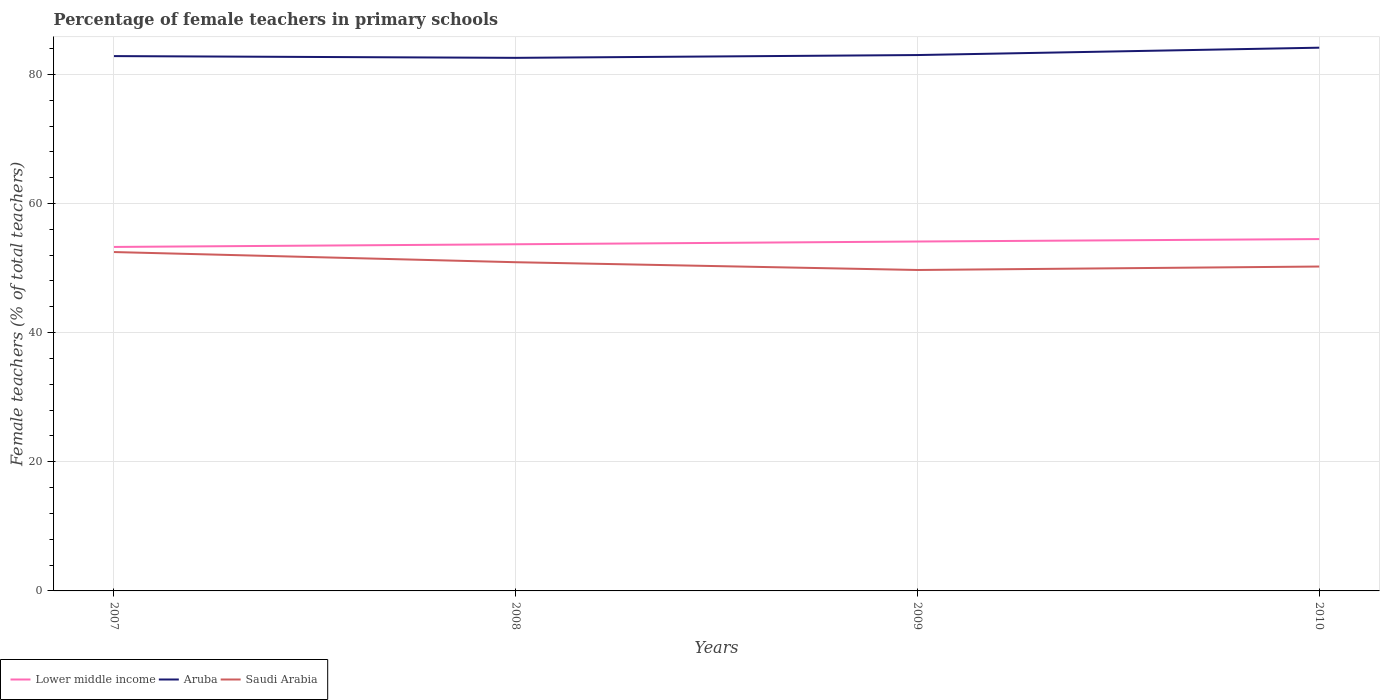How many different coloured lines are there?
Offer a terse response. 3. Does the line corresponding to Aruba intersect with the line corresponding to Saudi Arabia?
Offer a terse response. No. Is the number of lines equal to the number of legend labels?
Ensure brevity in your answer.  Yes. Across all years, what is the maximum percentage of female teachers in Aruba?
Your answer should be compact. 82.56. In which year was the percentage of female teachers in Aruba maximum?
Your answer should be compact. 2008. What is the total percentage of female teachers in Saudi Arabia in the graph?
Offer a terse response. 0.67. What is the difference between the highest and the second highest percentage of female teachers in Aruba?
Your answer should be compact. 1.57. How many lines are there?
Provide a succinct answer. 3. Does the graph contain grids?
Ensure brevity in your answer.  Yes. Where does the legend appear in the graph?
Your response must be concise. Bottom left. How many legend labels are there?
Offer a very short reply. 3. What is the title of the graph?
Your answer should be compact. Percentage of female teachers in primary schools. Does "Liberia" appear as one of the legend labels in the graph?
Your answer should be compact. No. What is the label or title of the X-axis?
Provide a succinct answer. Years. What is the label or title of the Y-axis?
Your response must be concise. Female teachers (% of total teachers). What is the Female teachers (% of total teachers) of Lower middle income in 2007?
Your response must be concise. 53.27. What is the Female teachers (% of total teachers) of Aruba in 2007?
Keep it short and to the point. 82.83. What is the Female teachers (% of total teachers) in Saudi Arabia in 2007?
Offer a terse response. 52.48. What is the Female teachers (% of total teachers) of Lower middle income in 2008?
Give a very brief answer. 53.69. What is the Female teachers (% of total teachers) in Aruba in 2008?
Offer a very short reply. 82.56. What is the Female teachers (% of total teachers) of Saudi Arabia in 2008?
Your answer should be very brief. 50.91. What is the Female teachers (% of total teachers) of Lower middle income in 2009?
Keep it short and to the point. 54.11. What is the Female teachers (% of total teachers) of Aruba in 2009?
Provide a succinct answer. 82.99. What is the Female teachers (% of total teachers) of Saudi Arabia in 2009?
Your response must be concise. 49.7. What is the Female teachers (% of total teachers) in Lower middle income in 2010?
Ensure brevity in your answer.  54.49. What is the Female teachers (% of total teachers) of Aruba in 2010?
Ensure brevity in your answer.  84.13. What is the Female teachers (% of total teachers) in Saudi Arabia in 2010?
Your answer should be very brief. 50.24. Across all years, what is the maximum Female teachers (% of total teachers) of Lower middle income?
Your response must be concise. 54.49. Across all years, what is the maximum Female teachers (% of total teachers) of Aruba?
Keep it short and to the point. 84.13. Across all years, what is the maximum Female teachers (% of total teachers) of Saudi Arabia?
Keep it short and to the point. 52.48. Across all years, what is the minimum Female teachers (% of total teachers) of Lower middle income?
Ensure brevity in your answer.  53.27. Across all years, what is the minimum Female teachers (% of total teachers) in Aruba?
Provide a short and direct response. 82.56. Across all years, what is the minimum Female teachers (% of total teachers) in Saudi Arabia?
Provide a succinct answer. 49.7. What is the total Female teachers (% of total teachers) in Lower middle income in the graph?
Keep it short and to the point. 215.56. What is the total Female teachers (% of total teachers) in Aruba in the graph?
Make the answer very short. 332.5. What is the total Female teachers (% of total teachers) of Saudi Arabia in the graph?
Offer a terse response. 203.33. What is the difference between the Female teachers (% of total teachers) in Lower middle income in 2007 and that in 2008?
Ensure brevity in your answer.  -0.41. What is the difference between the Female teachers (% of total teachers) of Aruba in 2007 and that in 2008?
Make the answer very short. 0.27. What is the difference between the Female teachers (% of total teachers) of Saudi Arabia in 2007 and that in 2008?
Give a very brief answer. 1.57. What is the difference between the Female teachers (% of total teachers) of Lower middle income in 2007 and that in 2009?
Provide a short and direct response. -0.84. What is the difference between the Female teachers (% of total teachers) of Aruba in 2007 and that in 2009?
Offer a terse response. -0.16. What is the difference between the Female teachers (% of total teachers) in Saudi Arabia in 2007 and that in 2009?
Your answer should be very brief. 2.78. What is the difference between the Female teachers (% of total teachers) in Lower middle income in 2007 and that in 2010?
Offer a very short reply. -1.22. What is the difference between the Female teachers (% of total teachers) of Aruba in 2007 and that in 2010?
Your response must be concise. -1.3. What is the difference between the Female teachers (% of total teachers) in Saudi Arabia in 2007 and that in 2010?
Offer a very short reply. 2.24. What is the difference between the Female teachers (% of total teachers) of Lower middle income in 2008 and that in 2009?
Your response must be concise. -0.42. What is the difference between the Female teachers (% of total teachers) of Aruba in 2008 and that in 2009?
Keep it short and to the point. -0.43. What is the difference between the Female teachers (% of total teachers) of Saudi Arabia in 2008 and that in 2009?
Provide a succinct answer. 1.2. What is the difference between the Female teachers (% of total teachers) of Lower middle income in 2008 and that in 2010?
Your answer should be compact. -0.8. What is the difference between the Female teachers (% of total teachers) of Aruba in 2008 and that in 2010?
Provide a short and direct response. -1.57. What is the difference between the Female teachers (% of total teachers) in Saudi Arabia in 2008 and that in 2010?
Make the answer very short. 0.67. What is the difference between the Female teachers (% of total teachers) in Lower middle income in 2009 and that in 2010?
Your answer should be compact. -0.38. What is the difference between the Female teachers (% of total teachers) in Aruba in 2009 and that in 2010?
Your answer should be compact. -1.14. What is the difference between the Female teachers (% of total teachers) in Saudi Arabia in 2009 and that in 2010?
Offer a terse response. -0.53. What is the difference between the Female teachers (% of total teachers) of Lower middle income in 2007 and the Female teachers (% of total teachers) of Aruba in 2008?
Your response must be concise. -29.28. What is the difference between the Female teachers (% of total teachers) of Lower middle income in 2007 and the Female teachers (% of total teachers) of Saudi Arabia in 2008?
Provide a short and direct response. 2.37. What is the difference between the Female teachers (% of total teachers) in Aruba in 2007 and the Female teachers (% of total teachers) in Saudi Arabia in 2008?
Keep it short and to the point. 31.92. What is the difference between the Female teachers (% of total teachers) in Lower middle income in 2007 and the Female teachers (% of total teachers) in Aruba in 2009?
Offer a very short reply. -29.72. What is the difference between the Female teachers (% of total teachers) of Lower middle income in 2007 and the Female teachers (% of total teachers) of Saudi Arabia in 2009?
Offer a very short reply. 3.57. What is the difference between the Female teachers (% of total teachers) in Aruba in 2007 and the Female teachers (% of total teachers) in Saudi Arabia in 2009?
Your answer should be very brief. 33.12. What is the difference between the Female teachers (% of total teachers) in Lower middle income in 2007 and the Female teachers (% of total teachers) in Aruba in 2010?
Ensure brevity in your answer.  -30.86. What is the difference between the Female teachers (% of total teachers) of Lower middle income in 2007 and the Female teachers (% of total teachers) of Saudi Arabia in 2010?
Keep it short and to the point. 3.04. What is the difference between the Female teachers (% of total teachers) in Aruba in 2007 and the Female teachers (% of total teachers) in Saudi Arabia in 2010?
Your answer should be compact. 32.59. What is the difference between the Female teachers (% of total teachers) of Lower middle income in 2008 and the Female teachers (% of total teachers) of Aruba in 2009?
Your answer should be very brief. -29.3. What is the difference between the Female teachers (% of total teachers) in Lower middle income in 2008 and the Female teachers (% of total teachers) in Saudi Arabia in 2009?
Give a very brief answer. 3.98. What is the difference between the Female teachers (% of total teachers) of Aruba in 2008 and the Female teachers (% of total teachers) of Saudi Arabia in 2009?
Offer a very short reply. 32.85. What is the difference between the Female teachers (% of total teachers) of Lower middle income in 2008 and the Female teachers (% of total teachers) of Aruba in 2010?
Keep it short and to the point. -30.44. What is the difference between the Female teachers (% of total teachers) in Lower middle income in 2008 and the Female teachers (% of total teachers) in Saudi Arabia in 2010?
Give a very brief answer. 3.45. What is the difference between the Female teachers (% of total teachers) of Aruba in 2008 and the Female teachers (% of total teachers) of Saudi Arabia in 2010?
Your answer should be very brief. 32.32. What is the difference between the Female teachers (% of total teachers) in Lower middle income in 2009 and the Female teachers (% of total teachers) in Aruba in 2010?
Keep it short and to the point. -30.02. What is the difference between the Female teachers (% of total teachers) in Lower middle income in 2009 and the Female teachers (% of total teachers) in Saudi Arabia in 2010?
Offer a very short reply. 3.87. What is the difference between the Female teachers (% of total teachers) in Aruba in 2009 and the Female teachers (% of total teachers) in Saudi Arabia in 2010?
Give a very brief answer. 32.75. What is the average Female teachers (% of total teachers) in Lower middle income per year?
Give a very brief answer. 53.89. What is the average Female teachers (% of total teachers) of Aruba per year?
Provide a short and direct response. 83.13. What is the average Female teachers (% of total teachers) in Saudi Arabia per year?
Ensure brevity in your answer.  50.83. In the year 2007, what is the difference between the Female teachers (% of total teachers) in Lower middle income and Female teachers (% of total teachers) in Aruba?
Make the answer very short. -29.56. In the year 2007, what is the difference between the Female teachers (% of total teachers) of Lower middle income and Female teachers (% of total teachers) of Saudi Arabia?
Keep it short and to the point. 0.79. In the year 2007, what is the difference between the Female teachers (% of total teachers) in Aruba and Female teachers (% of total teachers) in Saudi Arabia?
Your answer should be compact. 30.35. In the year 2008, what is the difference between the Female teachers (% of total teachers) in Lower middle income and Female teachers (% of total teachers) in Aruba?
Offer a terse response. -28.87. In the year 2008, what is the difference between the Female teachers (% of total teachers) in Lower middle income and Female teachers (% of total teachers) in Saudi Arabia?
Ensure brevity in your answer.  2.78. In the year 2008, what is the difference between the Female teachers (% of total teachers) in Aruba and Female teachers (% of total teachers) in Saudi Arabia?
Provide a short and direct response. 31.65. In the year 2009, what is the difference between the Female teachers (% of total teachers) of Lower middle income and Female teachers (% of total teachers) of Aruba?
Give a very brief answer. -28.88. In the year 2009, what is the difference between the Female teachers (% of total teachers) in Lower middle income and Female teachers (% of total teachers) in Saudi Arabia?
Offer a terse response. 4.41. In the year 2009, what is the difference between the Female teachers (% of total teachers) in Aruba and Female teachers (% of total teachers) in Saudi Arabia?
Offer a terse response. 33.29. In the year 2010, what is the difference between the Female teachers (% of total teachers) in Lower middle income and Female teachers (% of total teachers) in Aruba?
Your answer should be very brief. -29.64. In the year 2010, what is the difference between the Female teachers (% of total teachers) in Lower middle income and Female teachers (% of total teachers) in Saudi Arabia?
Offer a terse response. 4.25. In the year 2010, what is the difference between the Female teachers (% of total teachers) of Aruba and Female teachers (% of total teachers) of Saudi Arabia?
Keep it short and to the point. 33.89. What is the ratio of the Female teachers (% of total teachers) in Saudi Arabia in 2007 to that in 2008?
Keep it short and to the point. 1.03. What is the ratio of the Female teachers (% of total teachers) of Lower middle income in 2007 to that in 2009?
Provide a short and direct response. 0.98. What is the ratio of the Female teachers (% of total teachers) of Saudi Arabia in 2007 to that in 2009?
Ensure brevity in your answer.  1.06. What is the ratio of the Female teachers (% of total teachers) of Lower middle income in 2007 to that in 2010?
Offer a terse response. 0.98. What is the ratio of the Female teachers (% of total teachers) of Aruba in 2007 to that in 2010?
Offer a very short reply. 0.98. What is the ratio of the Female teachers (% of total teachers) in Saudi Arabia in 2007 to that in 2010?
Offer a terse response. 1.04. What is the ratio of the Female teachers (% of total teachers) in Lower middle income in 2008 to that in 2009?
Make the answer very short. 0.99. What is the ratio of the Female teachers (% of total teachers) of Saudi Arabia in 2008 to that in 2009?
Give a very brief answer. 1.02. What is the ratio of the Female teachers (% of total teachers) in Lower middle income in 2008 to that in 2010?
Provide a short and direct response. 0.99. What is the ratio of the Female teachers (% of total teachers) in Aruba in 2008 to that in 2010?
Keep it short and to the point. 0.98. What is the ratio of the Female teachers (% of total teachers) of Saudi Arabia in 2008 to that in 2010?
Provide a short and direct response. 1.01. What is the ratio of the Female teachers (% of total teachers) of Lower middle income in 2009 to that in 2010?
Offer a very short reply. 0.99. What is the ratio of the Female teachers (% of total teachers) of Aruba in 2009 to that in 2010?
Provide a succinct answer. 0.99. What is the difference between the highest and the second highest Female teachers (% of total teachers) of Lower middle income?
Give a very brief answer. 0.38. What is the difference between the highest and the second highest Female teachers (% of total teachers) of Aruba?
Provide a succinct answer. 1.14. What is the difference between the highest and the second highest Female teachers (% of total teachers) of Saudi Arabia?
Your answer should be compact. 1.57. What is the difference between the highest and the lowest Female teachers (% of total teachers) in Lower middle income?
Your answer should be very brief. 1.22. What is the difference between the highest and the lowest Female teachers (% of total teachers) in Aruba?
Your answer should be very brief. 1.57. What is the difference between the highest and the lowest Female teachers (% of total teachers) of Saudi Arabia?
Your answer should be compact. 2.78. 